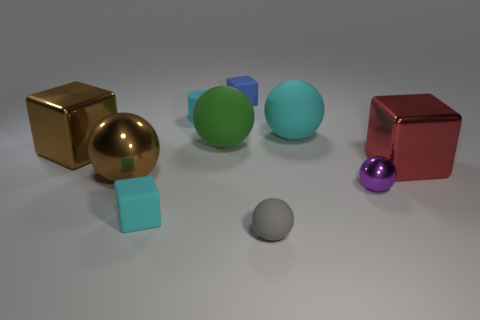What number of brown blocks are behind the ball that is in front of the tiny rubber block that is in front of the brown ball?
Your answer should be compact. 1. There is a red thing; is it the same shape as the cyan object that is to the left of the tiny cylinder?
Your answer should be very brief. Yes. Are there more tiny red matte balls than cylinders?
Your answer should be compact. No. Does the cyan thing that is in front of the purple metal thing have the same shape as the blue thing?
Ensure brevity in your answer.  Yes. Are there more green rubber things on the right side of the brown shiny block than tiny red metal cubes?
Give a very brief answer. Yes. There is a rubber object right of the gray matte object in front of the large cyan thing; what color is it?
Keep it short and to the point. Cyan. What number of large green matte balls are there?
Provide a succinct answer. 1. What number of small things are behind the tiny purple metal object and in front of the cyan cylinder?
Keep it short and to the point. 0. Do the cylinder and the rubber block in front of the brown ball have the same color?
Offer a very short reply. Yes. There is a large thing that is to the right of the cyan ball; what shape is it?
Ensure brevity in your answer.  Cube. 